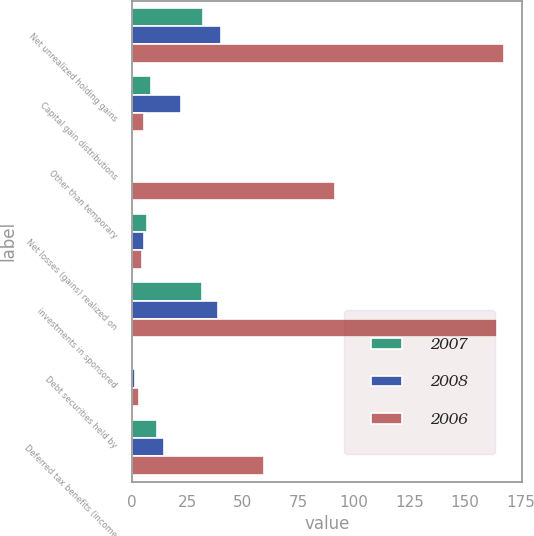Convert chart to OTSL. <chart><loc_0><loc_0><loc_500><loc_500><stacked_bar_chart><ecel><fcel>Net unrealized holding gains<fcel>Capital gain distributions<fcel>Other than temporary<fcel>Net losses (gains) realized on<fcel>investments in sponsored<fcel>Debt securities held by<fcel>Deferred tax benefits (income<nl><fcel>2007<fcel>32.2<fcel>8.8<fcel>0.5<fcel>6.8<fcel>31.7<fcel>0.5<fcel>11.4<nl><fcel>2008<fcel>40.2<fcel>22.1<fcel>0.3<fcel>5.5<fcel>38.7<fcel>1.5<fcel>14.5<nl><fcel>2006<fcel>167.5<fcel>5.6<fcel>91.3<fcel>4.5<fcel>164.5<fcel>3<fcel>59.4<nl></chart> 